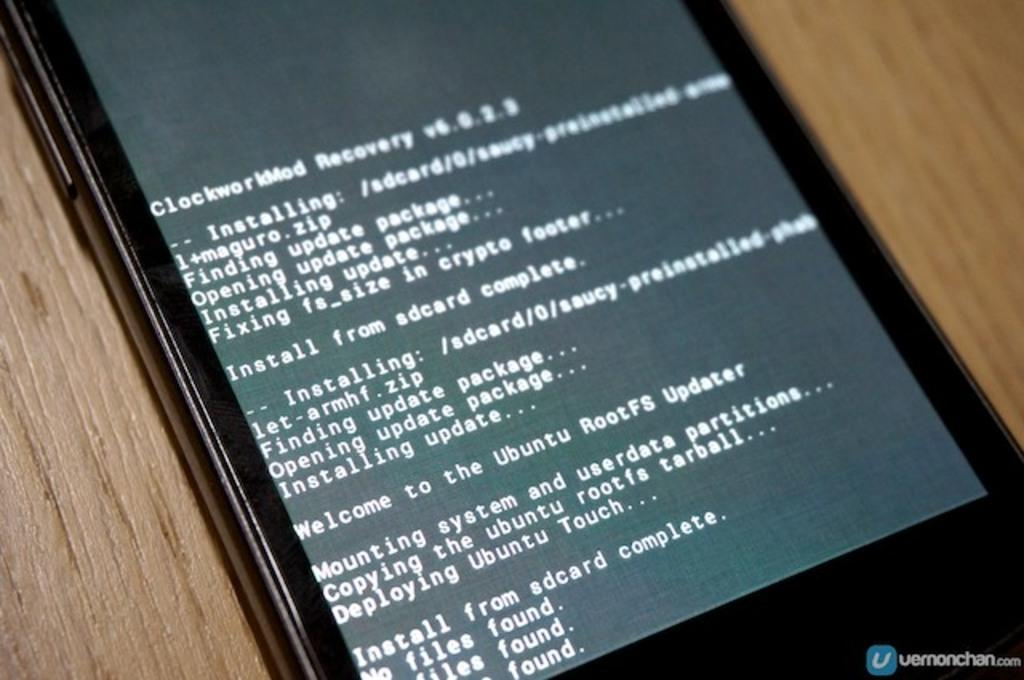Provide a one-sentence caption for the provided image. A tablet with white text saying things about installing and copying. 